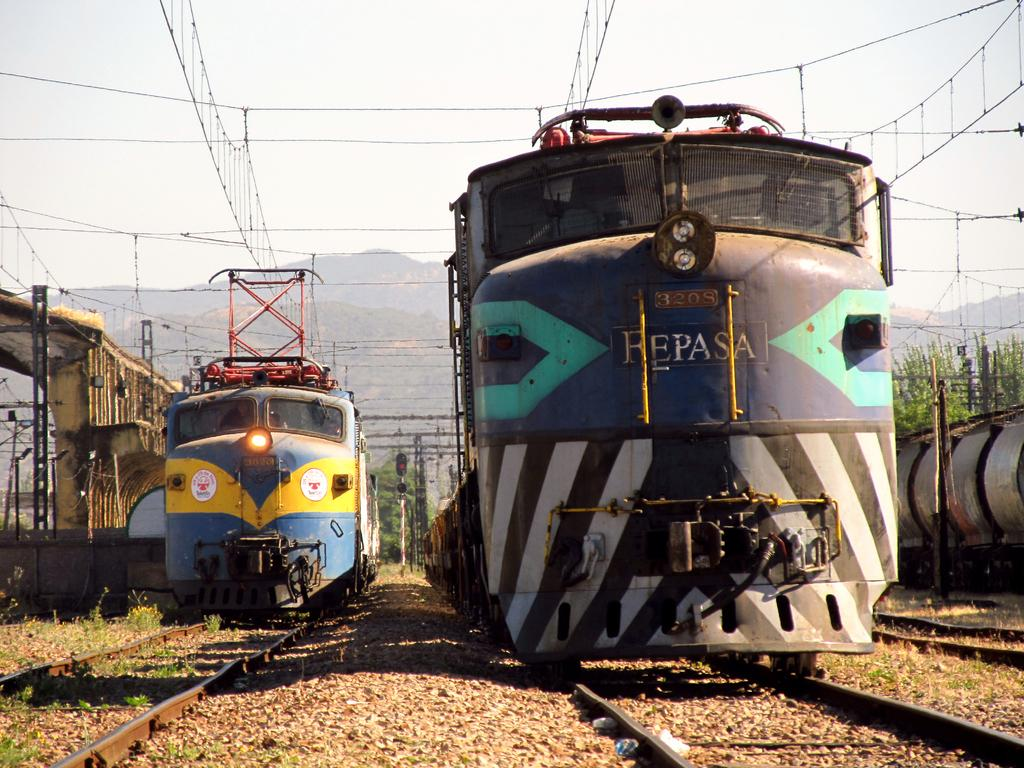What is present on the railway track in the image? There are trains on the railway track in the image. What can be seen in the background of the image? There are trees and mountains in the background of the image. What is visible above the trees and mountains in the image? The sky is visible in the image. What type of pest can be seen crawling on the train in the image? There are no pests visible on the train in the image. What property is associated with the train in the image? The image does not provide information about any specific property associated with the train. 